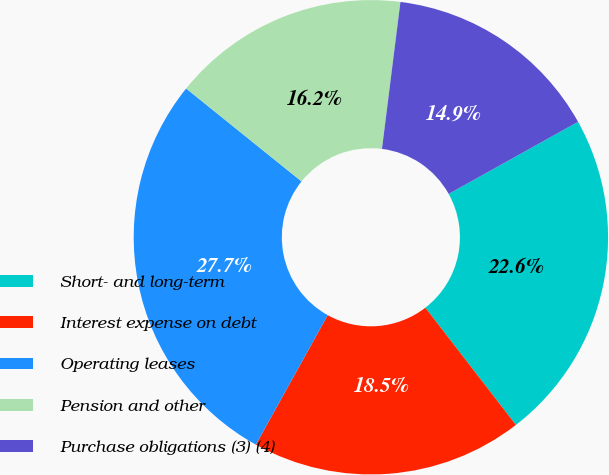Convert chart. <chart><loc_0><loc_0><loc_500><loc_500><pie_chart><fcel>Short- and long-term<fcel>Interest expense on debt<fcel>Operating leases<fcel>Pension and other<fcel>Purchase obligations (3) (4)<nl><fcel>22.62%<fcel>18.53%<fcel>27.73%<fcel>16.2%<fcel>14.92%<nl></chart> 